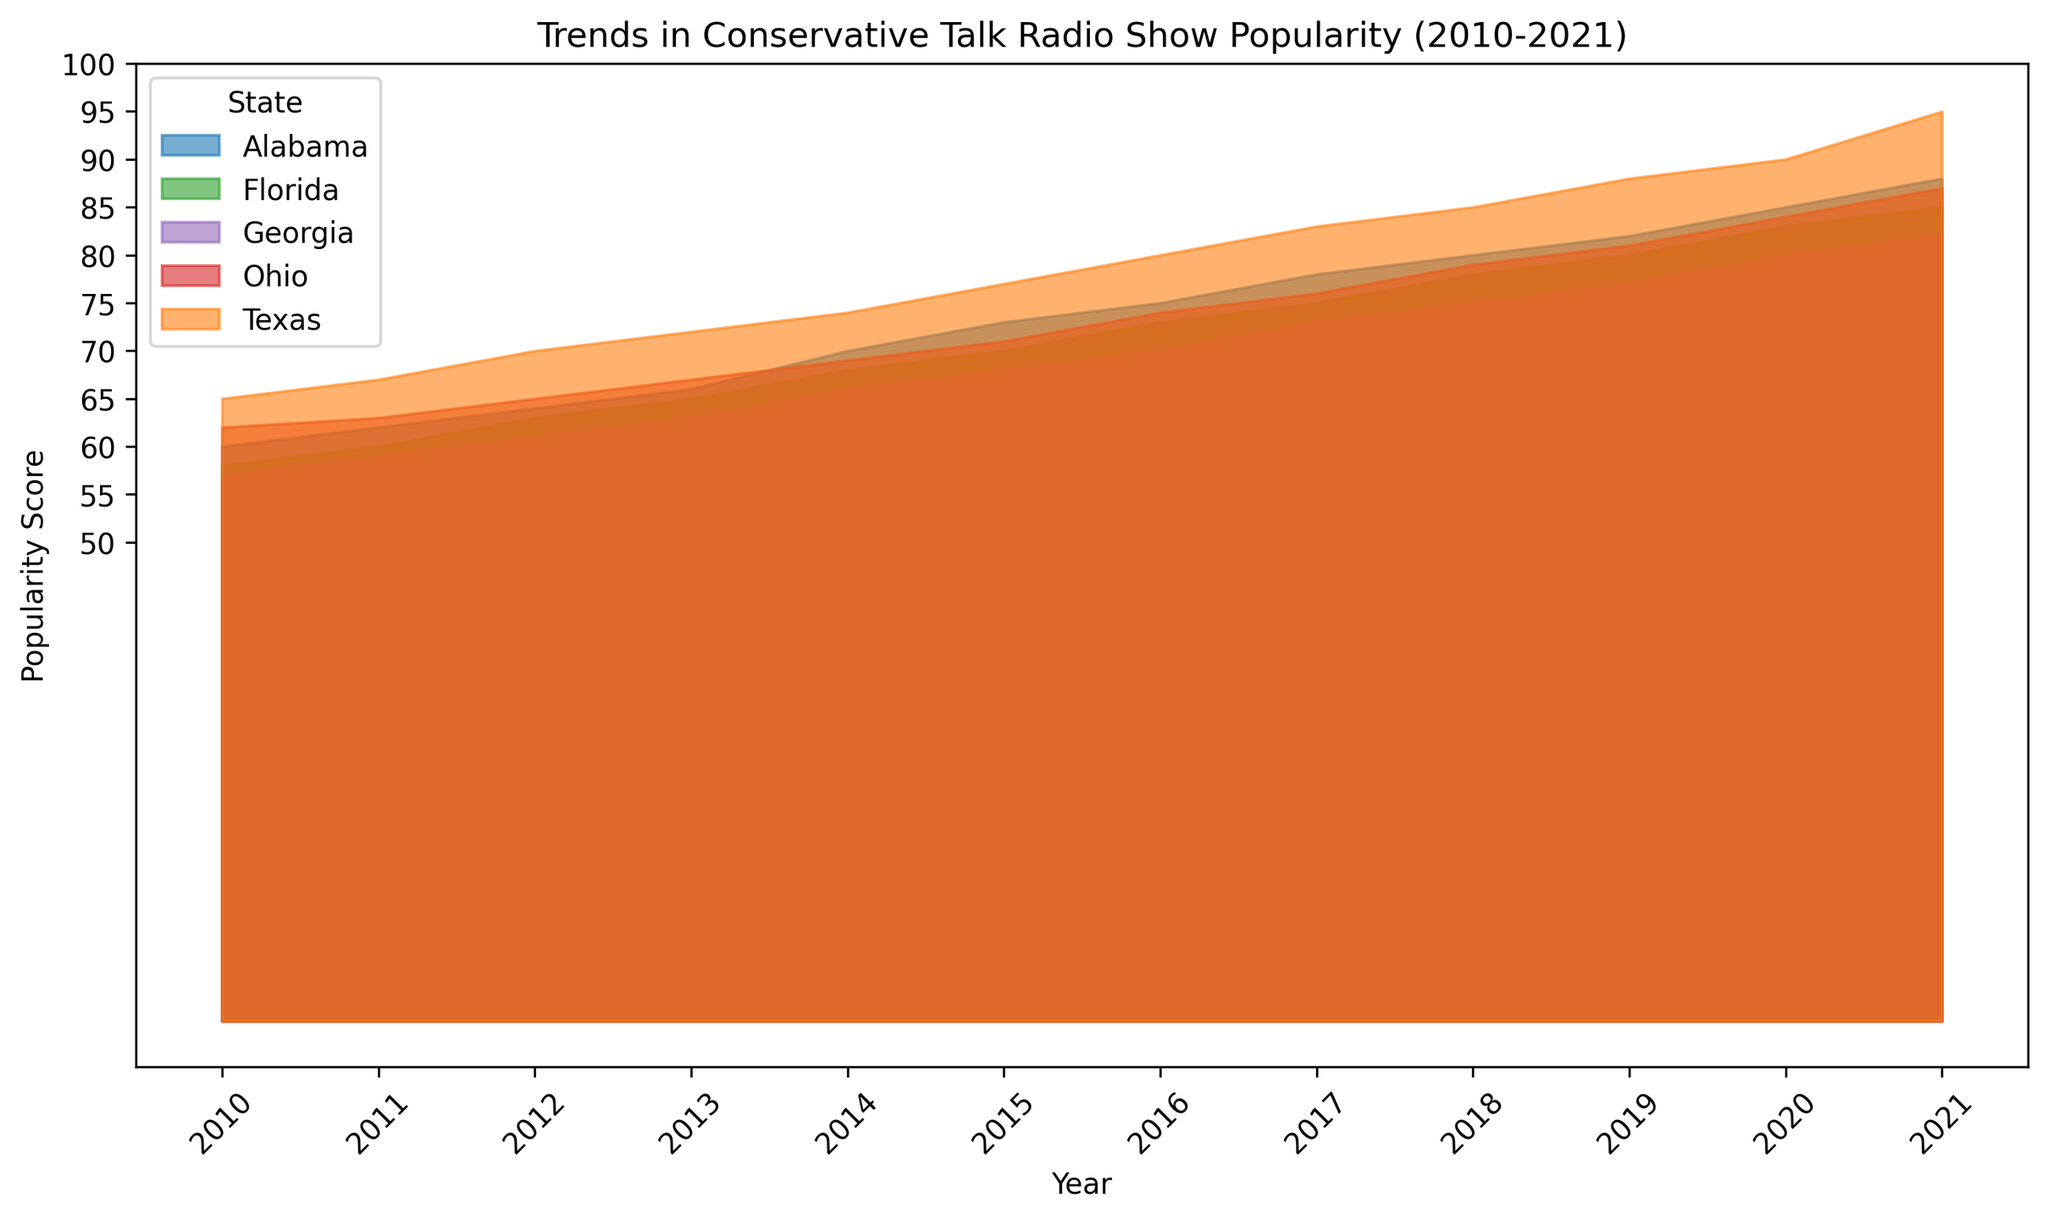Which state shows the highest popularity score in 2021? Look at the popularity scores for each state in the year 2021 and identify the highest value. Texas has a popularity score of 95 in 2021, which is the highest among all the states.
Answer: Texas Which state had the lowest popularity score in 2010? Check the popularity scores for all states in the year 2010 and find the lowest value. Georgia had a score of 57 in 2010, which is the lowest.
Answer: Georgia How much did the popularity score for Alabama increase from 2010 to 2020? Subtract Alabama’s popularity score in 2010 from its score in 2020. The score increased from 60 in 2010 to 85 in 2020, so 85 - 60 = 25.
Answer: 25 Which state showed the most significant increase in popularity from 2010 to 2021? For each state, calculate the difference in popularity scores between 2010 and 2021 and find the largest difference. Texas's score increased from 65 to 95, a rise of 30 points, which is the largest increase.
Answer: Texas Compare the popularity score of Florida and Ohio in 2015. Which was higher? Look at the scores for both Florida and Ohio in 2015. Florida's score is 70, and Ohio's score is 71, so Ohio's score is higher.
Answer: Ohio In which year did Georgia surpass a popularity score of 70? Identify the first year in which Georgia’s popularity score exceeds 70. Georgia surpassed a score of 70 in 2017 with a score of 73.
Answer: 2017 Which state had a consistent year-over-year increase in popularity from 2010 to 2021? Examine the trend for each state to see which one had continuous increases every year. All five states (Alabama, Texas, Florida, Ohio, and Georgia) had a continuous increase in their popularity scores year-over-year from 2010 to 2021.
Answer: All five states Compute the average popularity score for Alabama over the decade. Sum Alabama’s yearly popularity scores from 2010 to 2021 and then divide by the number of years (12). The total is 893, so 893 / 12 ≈ 74.42.
Answer: 74.42 Compare the popularity scores of all five states in 2015. Which state had the highest popularity score? Identify the popularity scores of each state in 2015, then determine which is the highest. Texas had the highest score with 77.
Answer: Texas 